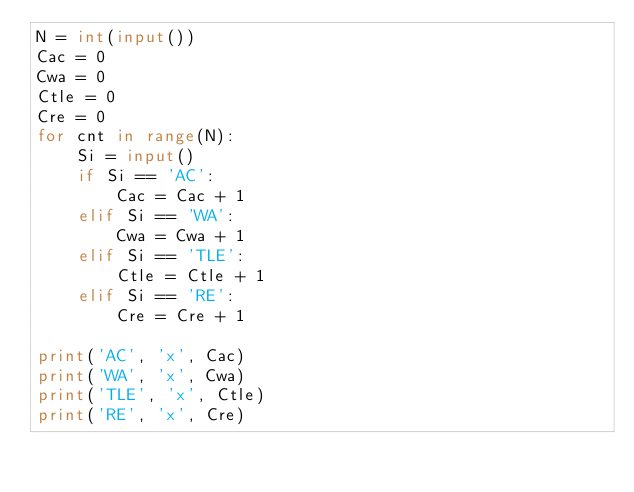Convert code to text. <code><loc_0><loc_0><loc_500><loc_500><_Python_>N = int(input())
Cac = 0
Cwa = 0
Ctle = 0
Cre = 0
for cnt in range(N):
    Si = input()
    if Si == 'AC':
        Cac = Cac + 1
    elif Si == 'WA':
        Cwa = Cwa + 1
    elif Si == 'TLE':
        Ctle = Ctle + 1
    elif Si == 'RE':
        Cre = Cre + 1

print('AC', 'x', Cac)
print('WA', 'x', Cwa)
print('TLE', 'x', Ctle)
print('RE', 'x', Cre)
</code> 